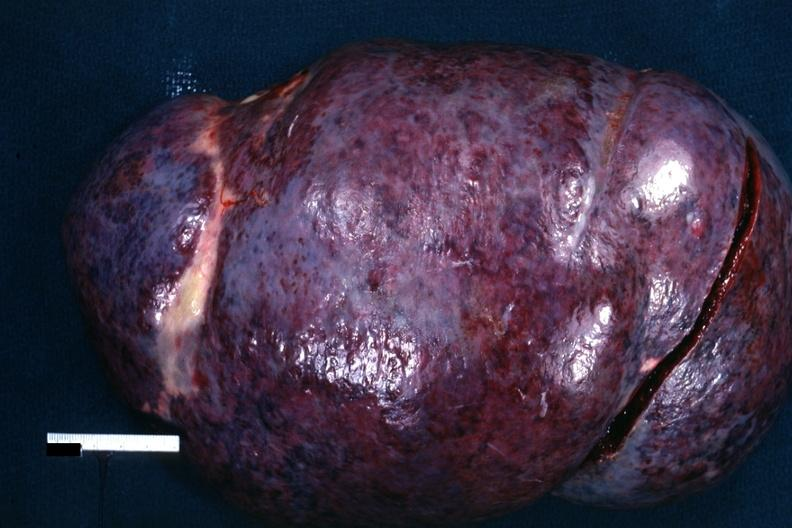what does this image show?
Answer the question using a single word or phrase. External view of massively enlarged spleen with purple color 